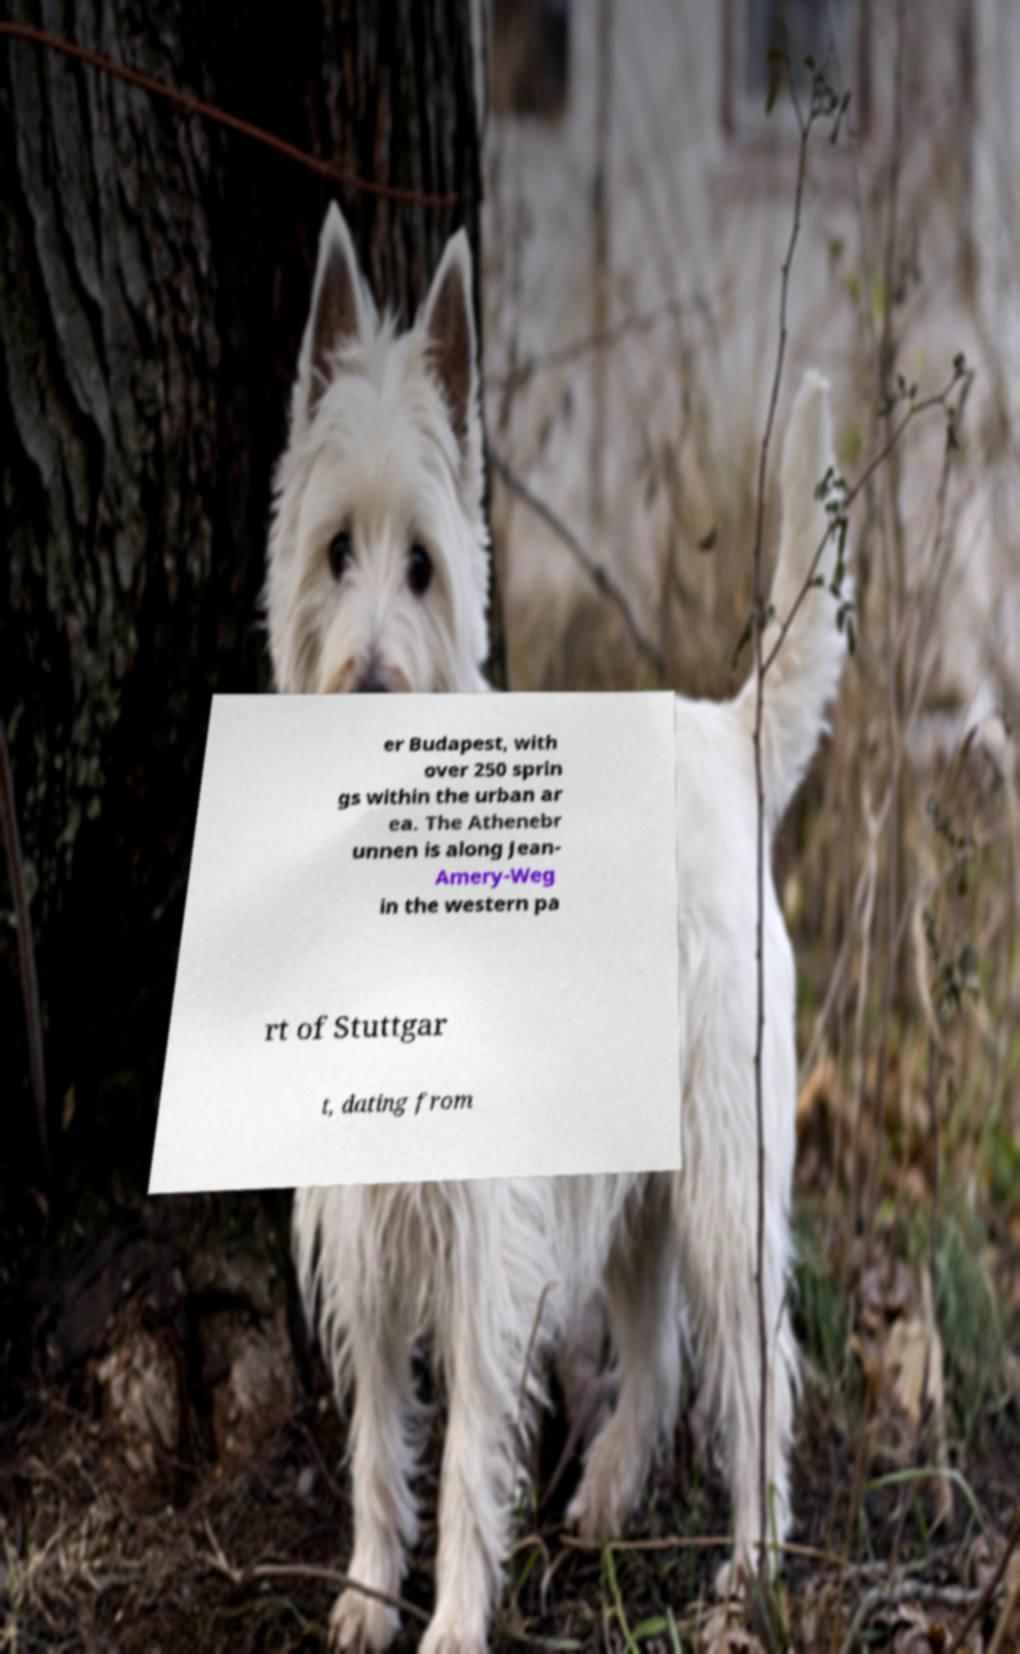Could you extract and type out the text from this image? er Budapest, with over 250 sprin gs within the urban ar ea. The Athenebr unnen is along Jean- Amery-Weg in the western pa rt of Stuttgar t, dating from 